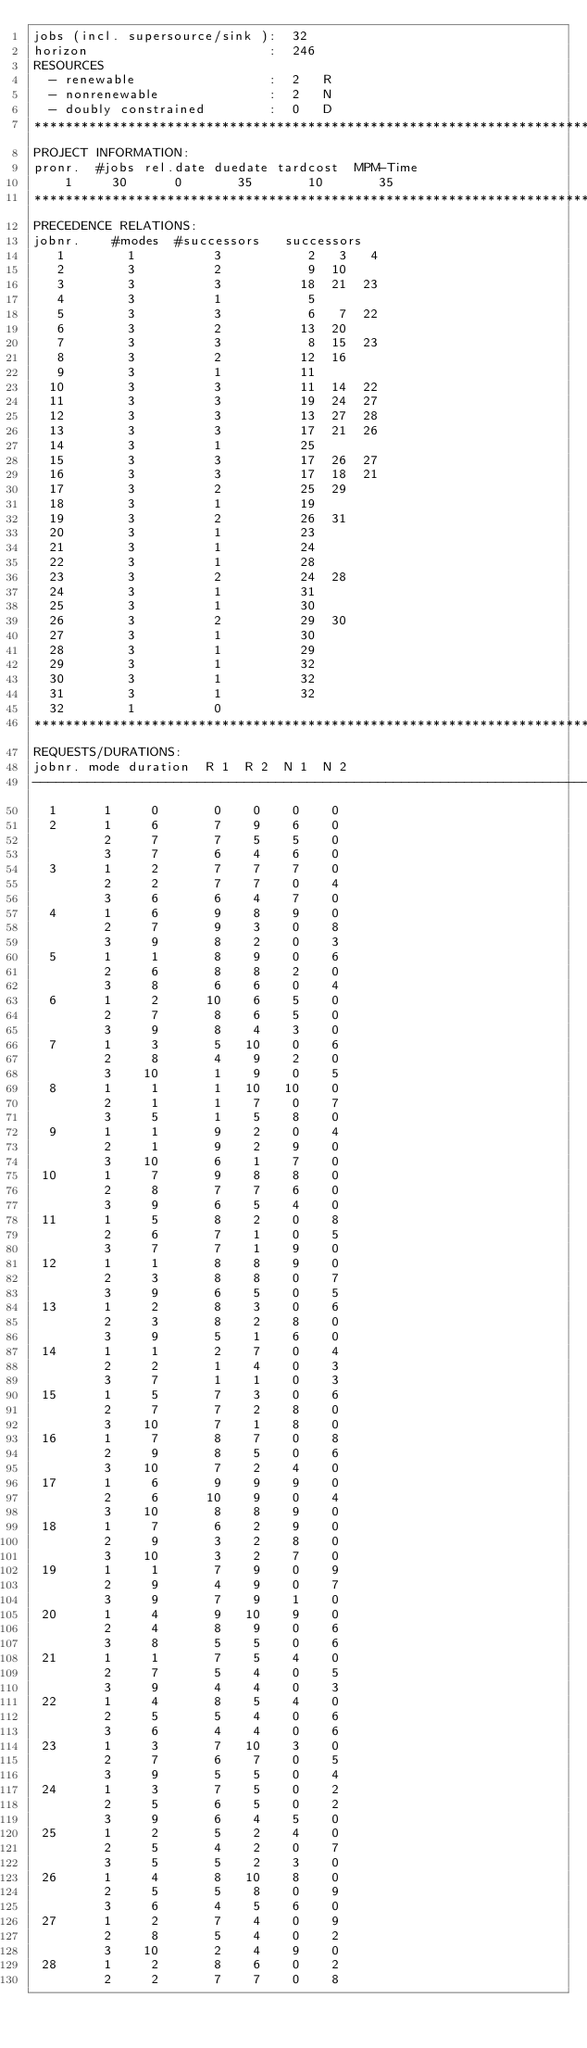Convert code to text. <code><loc_0><loc_0><loc_500><loc_500><_ObjectiveC_>jobs (incl. supersource/sink ):  32
horizon                       :  246
RESOURCES
  - renewable                 :  2   R
  - nonrenewable              :  2   N
  - doubly constrained        :  0   D
************************************************************************
PROJECT INFORMATION:
pronr.  #jobs rel.date duedate tardcost  MPM-Time
    1     30      0       35       10       35
************************************************************************
PRECEDENCE RELATIONS:
jobnr.    #modes  #successors   successors
   1        1          3           2   3   4
   2        3          2           9  10
   3        3          3          18  21  23
   4        3          1           5
   5        3          3           6   7  22
   6        3          2          13  20
   7        3          3           8  15  23
   8        3          2          12  16
   9        3          1          11
  10        3          3          11  14  22
  11        3          3          19  24  27
  12        3          3          13  27  28
  13        3          3          17  21  26
  14        3          1          25
  15        3          3          17  26  27
  16        3          3          17  18  21
  17        3          2          25  29
  18        3          1          19
  19        3          2          26  31
  20        3          1          23
  21        3          1          24
  22        3          1          28
  23        3          2          24  28
  24        3          1          31
  25        3          1          30
  26        3          2          29  30
  27        3          1          30
  28        3          1          29
  29        3          1          32
  30        3          1          32
  31        3          1          32
  32        1          0        
************************************************************************
REQUESTS/DURATIONS:
jobnr. mode duration  R 1  R 2  N 1  N 2
------------------------------------------------------------------------
  1      1     0       0    0    0    0
  2      1     6       7    9    6    0
         2     7       7    5    5    0
         3     7       6    4    6    0
  3      1     2       7    7    7    0
         2     2       7    7    0    4
         3     6       6    4    7    0
  4      1     6       9    8    9    0
         2     7       9    3    0    8
         3     9       8    2    0    3
  5      1     1       8    9    0    6
         2     6       8    8    2    0
         3     8       6    6    0    4
  6      1     2      10    6    5    0
         2     7       8    6    5    0
         3     9       8    4    3    0
  7      1     3       5   10    0    6
         2     8       4    9    2    0
         3    10       1    9    0    5
  8      1     1       1   10   10    0
         2     1       1    7    0    7
         3     5       1    5    8    0
  9      1     1       9    2    0    4
         2     1       9    2    9    0
         3    10       6    1    7    0
 10      1     7       9    8    8    0
         2     8       7    7    6    0
         3     9       6    5    4    0
 11      1     5       8    2    0    8
         2     6       7    1    0    5
         3     7       7    1    9    0
 12      1     1       8    8    9    0
         2     3       8    8    0    7
         3     9       6    5    0    5
 13      1     2       8    3    0    6
         2     3       8    2    8    0
         3     9       5    1    6    0
 14      1     1       2    7    0    4
         2     2       1    4    0    3
         3     7       1    1    0    3
 15      1     5       7    3    0    6
         2     7       7    2    8    0
         3    10       7    1    8    0
 16      1     7       8    7    0    8
         2     9       8    5    0    6
         3    10       7    2    4    0
 17      1     6       9    9    9    0
         2     6      10    9    0    4
         3    10       8    8    9    0
 18      1     7       6    2    9    0
         2     9       3    2    8    0
         3    10       3    2    7    0
 19      1     1       7    9    0    9
         2     9       4    9    0    7
         3     9       7    9    1    0
 20      1     4       9   10    9    0
         2     4       8    9    0    6
         3     8       5    5    0    6
 21      1     1       7    5    4    0
         2     7       5    4    0    5
         3     9       4    4    0    3
 22      1     4       8    5    4    0
         2     5       5    4    0    6
         3     6       4    4    0    6
 23      1     3       7   10    3    0
         2     7       6    7    0    5
         3     9       5    5    0    4
 24      1     3       7    5    0    2
         2     5       6    5    0    2
         3     9       6    4    5    0
 25      1     2       5    2    4    0
         2     5       4    2    0    7
         3     5       5    2    3    0
 26      1     4       8   10    8    0
         2     5       5    8    0    9
         3     6       4    5    6    0
 27      1     2       7    4    0    9
         2     8       5    4    0    2
         3    10       2    4    9    0
 28      1     2       8    6    0    2
         2     2       7    7    0    8</code> 